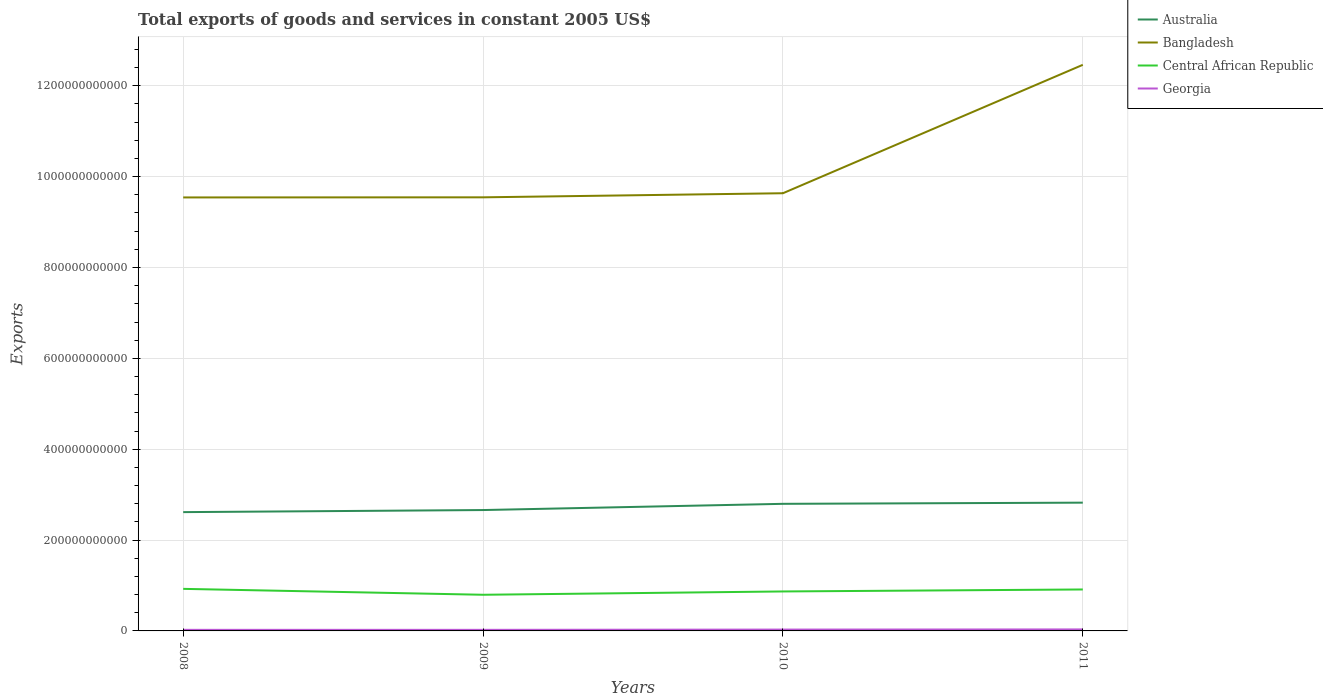Is the number of lines equal to the number of legend labels?
Provide a short and direct response. Yes. Across all years, what is the maximum total exports of goods and services in Georgia?
Provide a succinct answer. 2.37e+09. What is the total total exports of goods and services in Australia in the graph?
Give a very brief answer. -1.37e+1. What is the difference between the highest and the second highest total exports of goods and services in Bangladesh?
Make the answer very short. 2.92e+11. What is the difference between the highest and the lowest total exports of goods and services in Central African Republic?
Provide a short and direct response. 2. Is the total exports of goods and services in Georgia strictly greater than the total exports of goods and services in Bangladesh over the years?
Your answer should be very brief. Yes. How many lines are there?
Keep it short and to the point. 4. What is the difference between two consecutive major ticks on the Y-axis?
Your answer should be very brief. 2.00e+11. Are the values on the major ticks of Y-axis written in scientific E-notation?
Offer a very short reply. No. Does the graph contain any zero values?
Make the answer very short. No. How many legend labels are there?
Provide a succinct answer. 4. What is the title of the graph?
Keep it short and to the point. Total exports of goods and services in constant 2005 US$. Does "Mongolia" appear as one of the legend labels in the graph?
Your response must be concise. No. What is the label or title of the Y-axis?
Give a very brief answer. Exports. What is the Exports in Australia in 2008?
Make the answer very short. 2.62e+11. What is the Exports of Bangladesh in 2008?
Your answer should be compact. 9.54e+11. What is the Exports of Central African Republic in 2008?
Offer a very short reply. 9.26e+1. What is the Exports of Georgia in 2008?
Your answer should be compact. 2.37e+09. What is the Exports of Australia in 2009?
Offer a terse response. 2.66e+11. What is the Exports of Bangladesh in 2009?
Offer a very short reply. 9.55e+11. What is the Exports in Central African Republic in 2009?
Your answer should be very brief. 7.96e+1. What is the Exports in Georgia in 2009?
Provide a succinct answer. 2.37e+09. What is the Exports in Australia in 2010?
Your answer should be compact. 2.80e+11. What is the Exports in Bangladesh in 2010?
Provide a succinct answer. 9.63e+11. What is the Exports in Central African Republic in 2010?
Your response must be concise. 8.69e+1. What is the Exports in Georgia in 2010?
Provide a succinct answer. 2.96e+09. What is the Exports of Australia in 2011?
Offer a very short reply. 2.82e+11. What is the Exports in Bangladesh in 2011?
Make the answer very short. 1.25e+12. What is the Exports in Central African Republic in 2011?
Your answer should be very brief. 9.13e+1. What is the Exports in Georgia in 2011?
Make the answer very short. 3.28e+09. Across all years, what is the maximum Exports of Australia?
Your answer should be compact. 2.82e+11. Across all years, what is the maximum Exports in Bangladesh?
Give a very brief answer. 1.25e+12. Across all years, what is the maximum Exports in Central African Republic?
Make the answer very short. 9.26e+1. Across all years, what is the maximum Exports in Georgia?
Ensure brevity in your answer.  3.28e+09. Across all years, what is the minimum Exports of Australia?
Provide a succinct answer. 2.62e+11. Across all years, what is the minimum Exports in Bangladesh?
Keep it short and to the point. 9.54e+11. Across all years, what is the minimum Exports of Central African Republic?
Give a very brief answer. 7.96e+1. Across all years, what is the minimum Exports in Georgia?
Give a very brief answer. 2.37e+09. What is the total Exports in Australia in the graph?
Ensure brevity in your answer.  1.09e+12. What is the total Exports in Bangladesh in the graph?
Your answer should be very brief. 4.12e+12. What is the total Exports of Central African Republic in the graph?
Make the answer very short. 3.50e+11. What is the total Exports in Georgia in the graph?
Offer a very short reply. 1.10e+1. What is the difference between the Exports in Australia in 2008 and that in 2009?
Your answer should be very brief. -4.58e+09. What is the difference between the Exports in Bangladesh in 2008 and that in 2009?
Your answer should be very brief. -2.72e+08. What is the difference between the Exports in Central African Republic in 2008 and that in 2009?
Offer a terse response. 1.30e+1. What is the difference between the Exports in Georgia in 2008 and that in 2009?
Provide a short and direct response. 2.86e+05. What is the difference between the Exports of Australia in 2008 and that in 2010?
Keep it short and to the point. -1.83e+1. What is the difference between the Exports of Bangladesh in 2008 and that in 2010?
Offer a terse response. -9.26e+09. What is the difference between the Exports in Central African Republic in 2008 and that in 2010?
Keep it short and to the point. 5.71e+09. What is the difference between the Exports in Georgia in 2008 and that in 2010?
Provide a short and direct response. -5.88e+08. What is the difference between the Exports of Australia in 2008 and that in 2011?
Provide a short and direct response. -2.09e+1. What is the difference between the Exports in Bangladesh in 2008 and that in 2011?
Provide a short and direct response. -2.92e+11. What is the difference between the Exports in Central African Republic in 2008 and that in 2011?
Give a very brief answer. 1.33e+09. What is the difference between the Exports of Georgia in 2008 and that in 2011?
Offer a very short reply. -9.17e+08. What is the difference between the Exports of Australia in 2009 and that in 2010?
Provide a succinct answer. -1.37e+1. What is the difference between the Exports in Bangladesh in 2009 and that in 2010?
Provide a short and direct response. -8.99e+09. What is the difference between the Exports in Central African Republic in 2009 and that in 2010?
Offer a very short reply. -7.29e+09. What is the difference between the Exports in Georgia in 2009 and that in 2010?
Your response must be concise. -5.89e+08. What is the difference between the Exports in Australia in 2009 and that in 2011?
Provide a short and direct response. -1.63e+1. What is the difference between the Exports in Bangladesh in 2009 and that in 2011?
Provide a succinct answer. -2.92e+11. What is the difference between the Exports of Central African Republic in 2009 and that in 2011?
Your answer should be compact. -1.17e+1. What is the difference between the Exports of Georgia in 2009 and that in 2011?
Offer a very short reply. -9.18e+08. What is the difference between the Exports of Australia in 2010 and that in 2011?
Give a very brief answer. -2.60e+09. What is the difference between the Exports in Bangladesh in 2010 and that in 2011?
Keep it short and to the point. -2.83e+11. What is the difference between the Exports of Central African Republic in 2010 and that in 2011?
Ensure brevity in your answer.  -4.38e+09. What is the difference between the Exports in Georgia in 2010 and that in 2011?
Make the answer very short. -3.29e+08. What is the difference between the Exports of Australia in 2008 and the Exports of Bangladesh in 2009?
Provide a succinct answer. -6.93e+11. What is the difference between the Exports in Australia in 2008 and the Exports in Central African Republic in 2009?
Give a very brief answer. 1.82e+11. What is the difference between the Exports of Australia in 2008 and the Exports of Georgia in 2009?
Your answer should be very brief. 2.59e+11. What is the difference between the Exports in Bangladesh in 2008 and the Exports in Central African Republic in 2009?
Ensure brevity in your answer.  8.75e+11. What is the difference between the Exports in Bangladesh in 2008 and the Exports in Georgia in 2009?
Make the answer very short. 9.52e+11. What is the difference between the Exports of Central African Republic in 2008 and the Exports of Georgia in 2009?
Your answer should be compact. 9.02e+1. What is the difference between the Exports in Australia in 2008 and the Exports in Bangladesh in 2010?
Provide a short and direct response. -7.02e+11. What is the difference between the Exports in Australia in 2008 and the Exports in Central African Republic in 2010?
Your answer should be very brief. 1.75e+11. What is the difference between the Exports in Australia in 2008 and the Exports in Georgia in 2010?
Your response must be concise. 2.59e+11. What is the difference between the Exports in Bangladesh in 2008 and the Exports in Central African Republic in 2010?
Your answer should be compact. 8.67e+11. What is the difference between the Exports in Bangladesh in 2008 and the Exports in Georgia in 2010?
Offer a very short reply. 9.51e+11. What is the difference between the Exports of Central African Republic in 2008 and the Exports of Georgia in 2010?
Provide a short and direct response. 8.96e+1. What is the difference between the Exports of Australia in 2008 and the Exports of Bangladesh in 2011?
Keep it short and to the point. -9.85e+11. What is the difference between the Exports in Australia in 2008 and the Exports in Central African Republic in 2011?
Ensure brevity in your answer.  1.70e+11. What is the difference between the Exports of Australia in 2008 and the Exports of Georgia in 2011?
Offer a very short reply. 2.58e+11. What is the difference between the Exports in Bangladesh in 2008 and the Exports in Central African Republic in 2011?
Your answer should be compact. 8.63e+11. What is the difference between the Exports of Bangladesh in 2008 and the Exports of Georgia in 2011?
Provide a short and direct response. 9.51e+11. What is the difference between the Exports in Central African Republic in 2008 and the Exports in Georgia in 2011?
Ensure brevity in your answer.  8.93e+1. What is the difference between the Exports in Australia in 2009 and the Exports in Bangladesh in 2010?
Your answer should be very brief. -6.97e+11. What is the difference between the Exports in Australia in 2009 and the Exports in Central African Republic in 2010?
Keep it short and to the point. 1.79e+11. What is the difference between the Exports of Australia in 2009 and the Exports of Georgia in 2010?
Offer a very short reply. 2.63e+11. What is the difference between the Exports of Bangladesh in 2009 and the Exports of Central African Republic in 2010?
Offer a very short reply. 8.68e+11. What is the difference between the Exports in Bangladesh in 2009 and the Exports in Georgia in 2010?
Keep it short and to the point. 9.52e+11. What is the difference between the Exports in Central African Republic in 2009 and the Exports in Georgia in 2010?
Give a very brief answer. 7.66e+1. What is the difference between the Exports in Australia in 2009 and the Exports in Bangladesh in 2011?
Make the answer very short. -9.80e+11. What is the difference between the Exports of Australia in 2009 and the Exports of Central African Republic in 2011?
Make the answer very short. 1.75e+11. What is the difference between the Exports in Australia in 2009 and the Exports in Georgia in 2011?
Keep it short and to the point. 2.63e+11. What is the difference between the Exports of Bangladesh in 2009 and the Exports of Central African Republic in 2011?
Keep it short and to the point. 8.63e+11. What is the difference between the Exports in Bangladesh in 2009 and the Exports in Georgia in 2011?
Offer a terse response. 9.51e+11. What is the difference between the Exports of Central African Republic in 2009 and the Exports of Georgia in 2011?
Offer a very short reply. 7.63e+1. What is the difference between the Exports in Australia in 2010 and the Exports in Bangladesh in 2011?
Your response must be concise. -9.66e+11. What is the difference between the Exports in Australia in 2010 and the Exports in Central African Republic in 2011?
Offer a very short reply. 1.89e+11. What is the difference between the Exports of Australia in 2010 and the Exports of Georgia in 2011?
Make the answer very short. 2.76e+11. What is the difference between the Exports of Bangladesh in 2010 and the Exports of Central African Republic in 2011?
Your answer should be very brief. 8.72e+11. What is the difference between the Exports in Bangladesh in 2010 and the Exports in Georgia in 2011?
Provide a short and direct response. 9.60e+11. What is the difference between the Exports in Central African Republic in 2010 and the Exports in Georgia in 2011?
Your answer should be very brief. 8.36e+1. What is the average Exports in Australia per year?
Offer a very short reply. 2.72e+11. What is the average Exports of Bangladesh per year?
Make the answer very short. 1.03e+12. What is the average Exports of Central African Republic per year?
Your answer should be compact. 8.76e+1. What is the average Exports in Georgia per year?
Provide a succinct answer. 2.74e+09. In the year 2008, what is the difference between the Exports of Australia and Exports of Bangladesh?
Offer a terse response. -6.93e+11. In the year 2008, what is the difference between the Exports of Australia and Exports of Central African Republic?
Your answer should be compact. 1.69e+11. In the year 2008, what is the difference between the Exports in Australia and Exports in Georgia?
Offer a terse response. 2.59e+11. In the year 2008, what is the difference between the Exports of Bangladesh and Exports of Central African Republic?
Your answer should be very brief. 8.62e+11. In the year 2008, what is the difference between the Exports of Bangladesh and Exports of Georgia?
Make the answer very short. 9.52e+11. In the year 2008, what is the difference between the Exports of Central African Republic and Exports of Georgia?
Provide a succinct answer. 9.02e+1. In the year 2009, what is the difference between the Exports in Australia and Exports in Bangladesh?
Give a very brief answer. -6.88e+11. In the year 2009, what is the difference between the Exports of Australia and Exports of Central African Republic?
Your answer should be compact. 1.87e+11. In the year 2009, what is the difference between the Exports in Australia and Exports in Georgia?
Give a very brief answer. 2.64e+11. In the year 2009, what is the difference between the Exports of Bangladesh and Exports of Central African Republic?
Make the answer very short. 8.75e+11. In the year 2009, what is the difference between the Exports in Bangladesh and Exports in Georgia?
Keep it short and to the point. 9.52e+11. In the year 2009, what is the difference between the Exports of Central African Republic and Exports of Georgia?
Provide a succinct answer. 7.72e+1. In the year 2010, what is the difference between the Exports of Australia and Exports of Bangladesh?
Offer a terse response. -6.84e+11. In the year 2010, what is the difference between the Exports of Australia and Exports of Central African Republic?
Make the answer very short. 1.93e+11. In the year 2010, what is the difference between the Exports in Australia and Exports in Georgia?
Your response must be concise. 2.77e+11. In the year 2010, what is the difference between the Exports of Bangladesh and Exports of Central African Republic?
Your response must be concise. 8.77e+11. In the year 2010, what is the difference between the Exports in Bangladesh and Exports in Georgia?
Your response must be concise. 9.61e+11. In the year 2010, what is the difference between the Exports in Central African Republic and Exports in Georgia?
Give a very brief answer. 8.39e+1. In the year 2011, what is the difference between the Exports of Australia and Exports of Bangladesh?
Give a very brief answer. -9.64e+11. In the year 2011, what is the difference between the Exports of Australia and Exports of Central African Republic?
Offer a terse response. 1.91e+11. In the year 2011, what is the difference between the Exports of Australia and Exports of Georgia?
Offer a terse response. 2.79e+11. In the year 2011, what is the difference between the Exports in Bangladesh and Exports in Central African Republic?
Offer a very short reply. 1.15e+12. In the year 2011, what is the difference between the Exports of Bangladesh and Exports of Georgia?
Provide a succinct answer. 1.24e+12. In the year 2011, what is the difference between the Exports of Central African Republic and Exports of Georgia?
Provide a succinct answer. 8.80e+1. What is the ratio of the Exports of Australia in 2008 to that in 2009?
Make the answer very short. 0.98. What is the ratio of the Exports in Bangladesh in 2008 to that in 2009?
Offer a very short reply. 1. What is the ratio of the Exports of Central African Republic in 2008 to that in 2009?
Offer a very short reply. 1.16. What is the ratio of the Exports of Australia in 2008 to that in 2010?
Offer a terse response. 0.93. What is the ratio of the Exports in Bangladesh in 2008 to that in 2010?
Your response must be concise. 0.99. What is the ratio of the Exports of Central African Republic in 2008 to that in 2010?
Offer a very short reply. 1.07. What is the ratio of the Exports in Georgia in 2008 to that in 2010?
Give a very brief answer. 0.8. What is the ratio of the Exports of Australia in 2008 to that in 2011?
Your response must be concise. 0.93. What is the ratio of the Exports of Bangladesh in 2008 to that in 2011?
Provide a succinct answer. 0.77. What is the ratio of the Exports in Central African Republic in 2008 to that in 2011?
Provide a short and direct response. 1.01. What is the ratio of the Exports in Georgia in 2008 to that in 2011?
Give a very brief answer. 0.72. What is the ratio of the Exports of Australia in 2009 to that in 2010?
Your answer should be very brief. 0.95. What is the ratio of the Exports of Bangladesh in 2009 to that in 2010?
Provide a succinct answer. 0.99. What is the ratio of the Exports of Central African Republic in 2009 to that in 2010?
Offer a terse response. 0.92. What is the ratio of the Exports of Georgia in 2009 to that in 2010?
Your answer should be very brief. 0.8. What is the ratio of the Exports of Australia in 2009 to that in 2011?
Offer a terse response. 0.94. What is the ratio of the Exports of Bangladesh in 2009 to that in 2011?
Provide a succinct answer. 0.77. What is the ratio of the Exports of Central African Republic in 2009 to that in 2011?
Give a very brief answer. 0.87. What is the ratio of the Exports in Georgia in 2009 to that in 2011?
Offer a terse response. 0.72. What is the ratio of the Exports of Bangladesh in 2010 to that in 2011?
Offer a very short reply. 0.77. What is the ratio of the Exports of Georgia in 2010 to that in 2011?
Offer a terse response. 0.9. What is the difference between the highest and the second highest Exports in Australia?
Provide a succinct answer. 2.60e+09. What is the difference between the highest and the second highest Exports of Bangladesh?
Provide a short and direct response. 2.83e+11. What is the difference between the highest and the second highest Exports of Central African Republic?
Give a very brief answer. 1.33e+09. What is the difference between the highest and the second highest Exports in Georgia?
Offer a terse response. 3.29e+08. What is the difference between the highest and the lowest Exports in Australia?
Give a very brief answer. 2.09e+1. What is the difference between the highest and the lowest Exports of Bangladesh?
Ensure brevity in your answer.  2.92e+11. What is the difference between the highest and the lowest Exports in Central African Republic?
Provide a succinct answer. 1.30e+1. What is the difference between the highest and the lowest Exports in Georgia?
Your answer should be compact. 9.18e+08. 